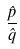Convert formula to latex. <formula><loc_0><loc_0><loc_500><loc_500>\frac { \hat { p } } { \hat { q } }</formula> 